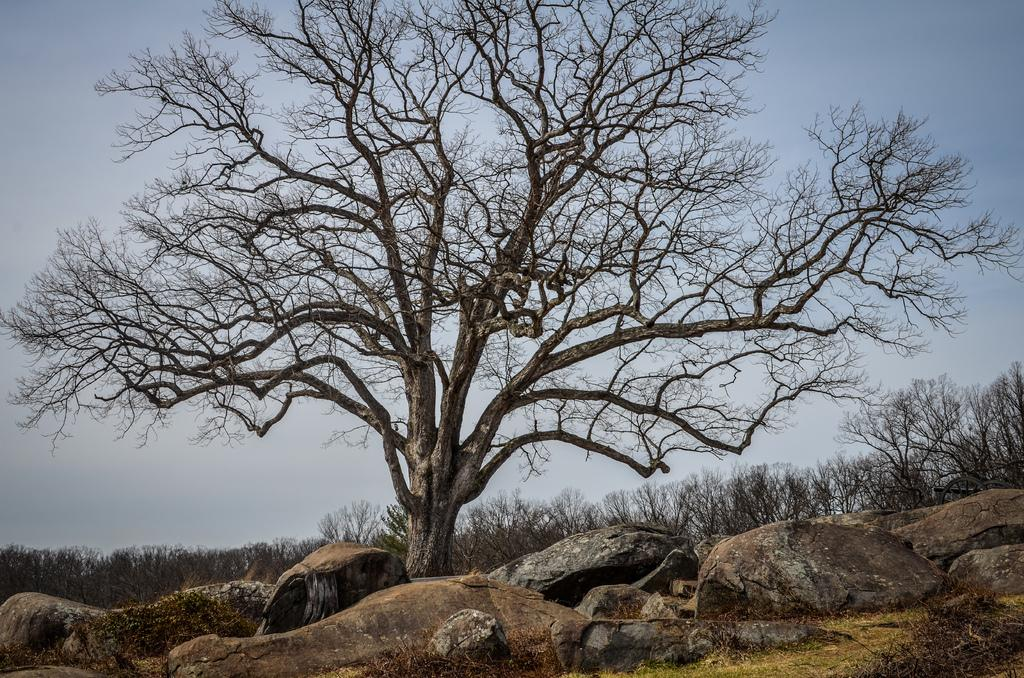What type of objects can be seen in the image? There are stones in the image. What can be seen in the background of the image? There are dried trees in the background of the image. What colors are visible in the sky in the image? The sky is blue and white in color. What is the profit made by the zinc in the image? There is no zinc present in the image, so it is not possible to determine any profit made by it. 